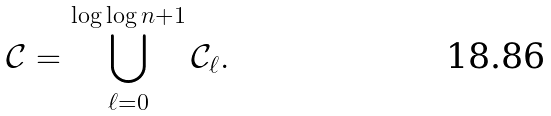<formula> <loc_0><loc_0><loc_500><loc_500>\mathcal { C } = \bigcup _ { \ell = 0 } ^ { \log \log n + 1 } \mathcal { C } _ { \ell } .</formula> 